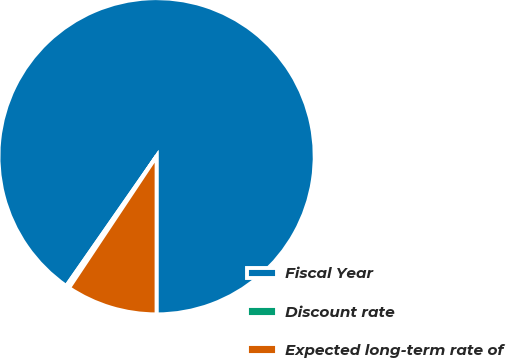<chart> <loc_0><loc_0><loc_500><loc_500><pie_chart><fcel>Fiscal Year<fcel>Discount rate<fcel>Expected long-term rate of<nl><fcel>90.32%<fcel>0.34%<fcel>9.34%<nl></chart> 